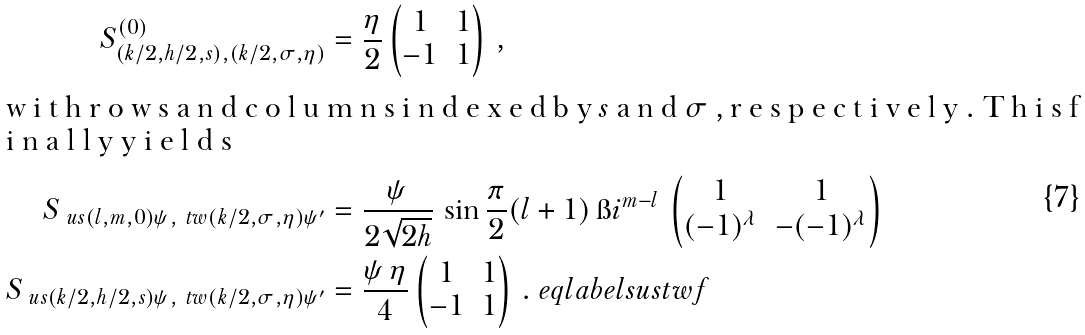<formula> <loc_0><loc_0><loc_500><loc_500>S ^ { ( 0 ) } _ { ( k / 2 , h / 2 , s ) , ( k / 2 , \sigma , \eta ) } & = \frac { \eta } { 2 } \begin{pmatrix} 1 & 1 \\ - 1 & 1 \end{pmatrix} \, , \\ \intertext { w i t h r o w s a n d c o l u m n s i n d e x e d b y $ s $ a n d $ \sigma $ , r e s p e c t i v e l y . T h i s f i n a l l y y i e l d s } S _ { \ u s ( l , m , 0 ) \psi , \ t w ( k / 2 , \sigma , \eta ) \psi ^ { \prime } } & = \frac { \psi } { 2 \sqrt { 2 h } } \, \sin \frac { \pi } { 2 } ( l + 1 ) \, \i i ^ { m - l } \, \begin{pmatrix} 1 & 1 \\ ( - 1 ) ^ { \lambda } & - ( - 1 ) ^ { \lambda } \end{pmatrix} \\ S _ { \ u s ( k / 2 , h / 2 , s ) \psi , \ t w ( k / 2 , \sigma , \eta ) \psi ^ { \prime } } & = \frac { \psi \, \eta } { 4 } \begin{pmatrix} 1 & 1 \\ - 1 & 1 \end{pmatrix} \, . \ e q l a b e l { s u s t w f }</formula> 